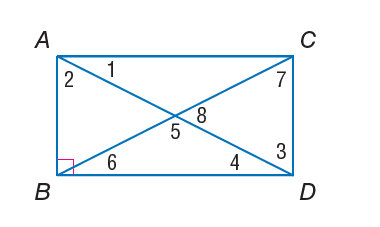Answer the mathemtical geometry problem and directly provide the correct option letter.
Question: Quadrilateral A B C D is a rectangle. m \angle 2 = 40. Find m \angle 1.
Choices: A: 40 B: 50 C: 90 D: 130 B 